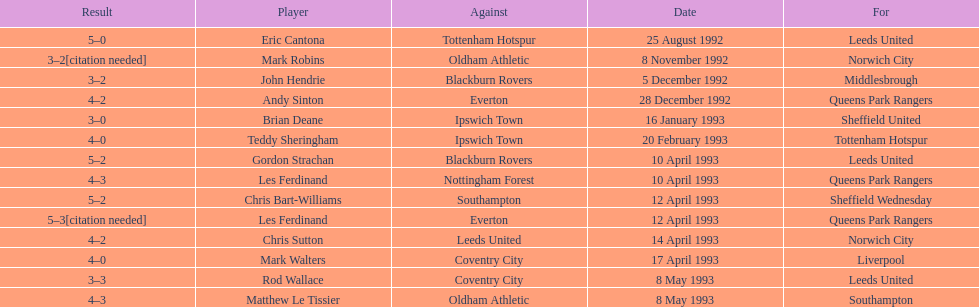In the premier league's 1992-1993 season, how many total hat tricks were accomplished by players? 14. 